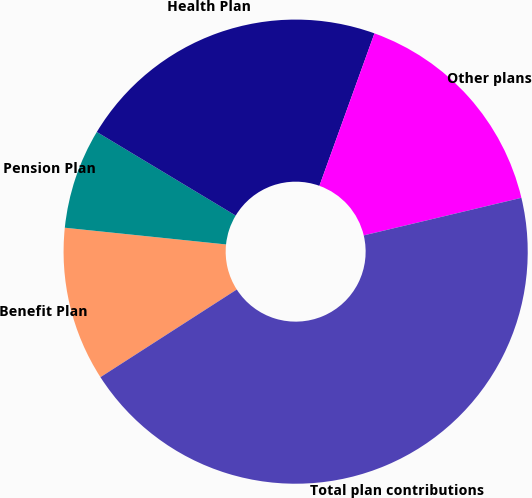Convert chart to OTSL. <chart><loc_0><loc_0><loc_500><loc_500><pie_chart><fcel>Benefit Plan<fcel>Pension Plan<fcel>Health Plan<fcel>Other plans<fcel>Total plan contributions<nl><fcel>10.74%<fcel>6.98%<fcel>21.89%<fcel>15.76%<fcel>44.63%<nl></chart> 